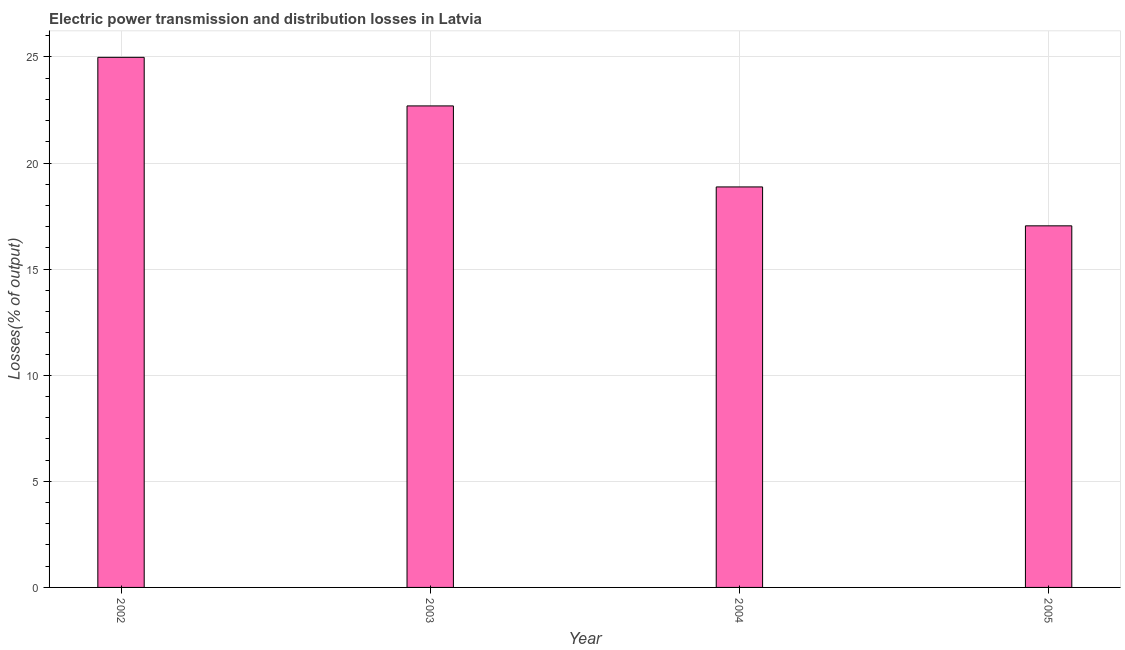Does the graph contain any zero values?
Your answer should be very brief. No. What is the title of the graph?
Make the answer very short. Electric power transmission and distribution losses in Latvia. What is the label or title of the X-axis?
Keep it short and to the point. Year. What is the label or title of the Y-axis?
Your answer should be very brief. Losses(% of output). What is the electric power transmission and distribution losses in 2002?
Make the answer very short. 24.98. Across all years, what is the maximum electric power transmission and distribution losses?
Ensure brevity in your answer.  24.98. Across all years, what is the minimum electric power transmission and distribution losses?
Provide a short and direct response. 17.04. In which year was the electric power transmission and distribution losses minimum?
Offer a very short reply. 2005. What is the sum of the electric power transmission and distribution losses?
Offer a terse response. 83.59. What is the difference between the electric power transmission and distribution losses in 2003 and 2005?
Keep it short and to the point. 5.65. What is the average electric power transmission and distribution losses per year?
Provide a succinct answer. 20.9. What is the median electric power transmission and distribution losses?
Provide a short and direct response. 20.78. Do a majority of the years between 2003 and 2005 (inclusive) have electric power transmission and distribution losses greater than 22 %?
Your answer should be very brief. No. What is the ratio of the electric power transmission and distribution losses in 2002 to that in 2004?
Your answer should be very brief. 1.32. What is the difference between the highest and the second highest electric power transmission and distribution losses?
Provide a succinct answer. 2.29. Is the sum of the electric power transmission and distribution losses in 2003 and 2005 greater than the maximum electric power transmission and distribution losses across all years?
Give a very brief answer. Yes. What is the difference between the highest and the lowest electric power transmission and distribution losses?
Make the answer very short. 7.94. In how many years, is the electric power transmission and distribution losses greater than the average electric power transmission and distribution losses taken over all years?
Provide a short and direct response. 2. Are all the bars in the graph horizontal?
Give a very brief answer. No. Are the values on the major ticks of Y-axis written in scientific E-notation?
Your response must be concise. No. What is the Losses(% of output) in 2002?
Your answer should be compact. 24.98. What is the Losses(% of output) in 2003?
Offer a terse response. 22.69. What is the Losses(% of output) in 2004?
Your answer should be very brief. 18.87. What is the Losses(% of output) of 2005?
Make the answer very short. 17.04. What is the difference between the Losses(% of output) in 2002 and 2003?
Offer a terse response. 2.29. What is the difference between the Losses(% of output) in 2002 and 2004?
Give a very brief answer. 6.11. What is the difference between the Losses(% of output) in 2002 and 2005?
Make the answer very short. 7.94. What is the difference between the Losses(% of output) in 2003 and 2004?
Your answer should be very brief. 3.82. What is the difference between the Losses(% of output) in 2003 and 2005?
Your response must be concise. 5.65. What is the difference between the Losses(% of output) in 2004 and 2005?
Give a very brief answer. 1.83. What is the ratio of the Losses(% of output) in 2002 to that in 2003?
Your answer should be compact. 1.1. What is the ratio of the Losses(% of output) in 2002 to that in 2004?
Keep it short and to the point. 1.32. What is the ratio of the Losses(% of output) in 2002 to that in 2005?
Provide a short and direct response. 1.47. What is the ratio of the Losses(% of output) in 2003 to that in 2004?
Provide a short and direct response. 1.2. What is the ratio of the Losses(% of output) in 2003 to that in 2005?
Provide a short and direct response. 1.33. What is the ratio of the Losses(% of output) in 2004 to that in 2005?
Offer a very short reply. 1.11. 